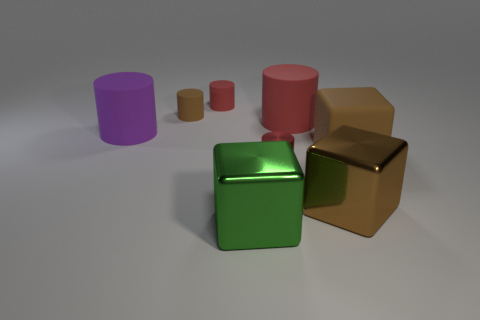Subtract all blue cubes. How many red cylinders are left? 3 Subtract all large red cylinders. How many cylinders are left? 4 Subtract all purple cylinders. How many cylinders are left? 4 Subtract all purple cylinders. Subtract all cyan blocks. How many cylinders are left? 4 Add 2 large green metal cylinders. How many objects exist? 10 Subtract all cubes. How many objects are left? 5 Subtract 0 cyan cylinders. How many objects are left? 8 Subtract all big brown shiny things. Subtract all red cylinders. How many objects are left? 4 Add 6 green cubes. How many green cubes are left? 7 Add 7 small red metal objects. How many small red metal objects exist? 8 